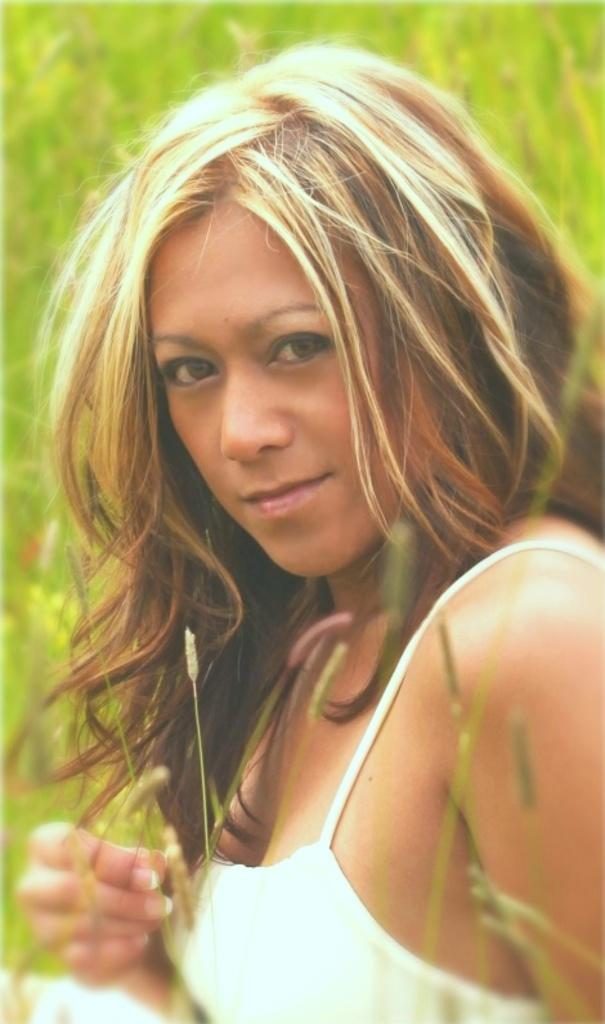What is the main subject of the image? The main subject of the image is a woman. What is the woman wearing in the image? The woman is wearing a white top. What color is the background of the image? The background of the image is green. Can you see any bun in the image? There is no bun present in the image. Is there a beam visible in the image? There is no beam visible in the image. 